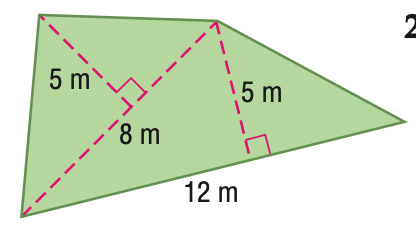Question: Find the area of the figure. Round to the nearest tenth if necessary.
Choices:
A. 40
B. 50
C. 60
D. 80
Answer with the letter. Answer: B 